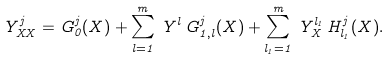<formula> <loc_0><loc_0><loc_500><loc_500>Y _ { X X } ^ { j } = G _ { 0 } ^ { j } ( X ) + \sum _ { l = 1 } ^ { m } \, Y ^ { l } \, G _ { 1 , l } ^ { j } ( X ) + \sum _ { l _ { 1 } = 1 } ^ { m } \, Y _ { X } ^ { l _ { 1 } } \, H _ { l _ { 1 } } ^ { j } ( X ) .</formula> 